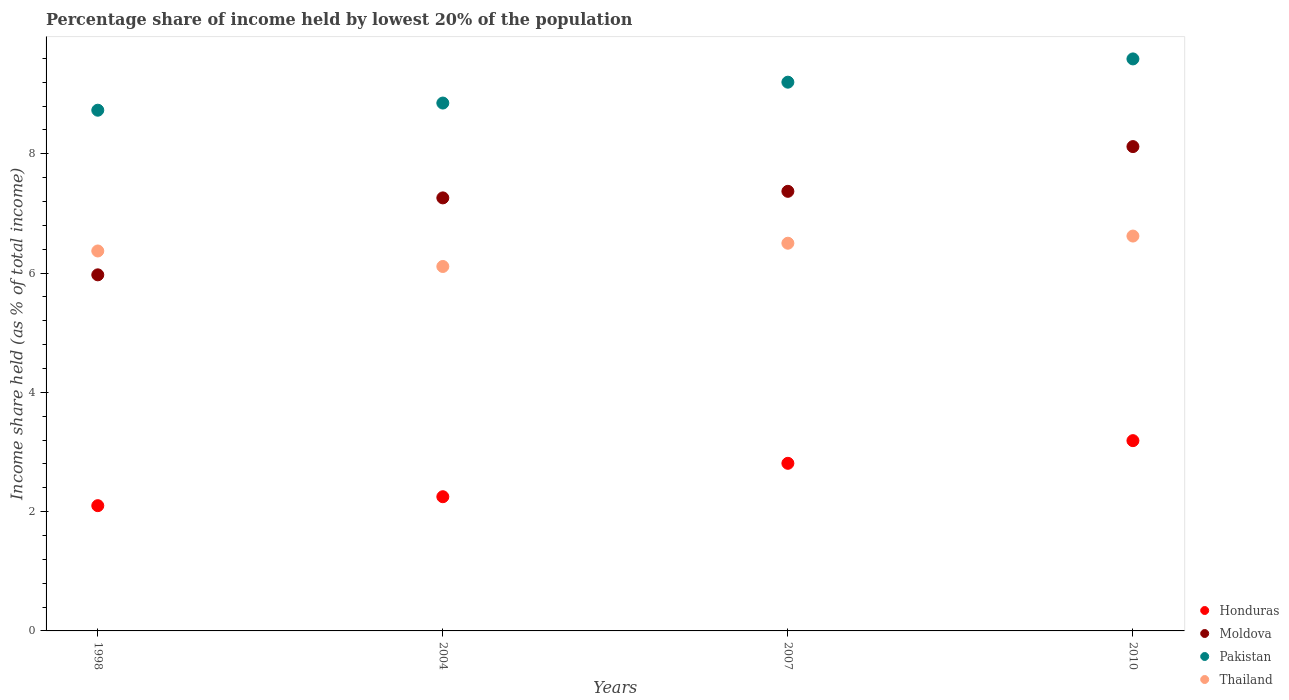How many different coloured dotlines are there?
Offer a very short reply. 4. What is the percentage share of income held by lowest 20% of the population in Pakistan in 2010?
Your answer should be compact. 9.59. Across all years, what is the maximum percentage share of income held by lowest 20% of the population in Thailand?
Keep it short and to the point. 6.62. Across all years, what is the minimum percentage share of income held by lowest 20% of the population in Pakistan?
Offer a very short reply. 8.73. In which year was the percentage share of income held by lowest 20% of the population in Honduras maximum?
Provide a succinct answer. 2010. What is the total percentage share of income held by lowest 20% of the population in Pakistan in the graph?
Provide a succinct answer. 36.37. What is the difference between the percentage share of income held by lowest 20% of the population in Honduras in 1998 and that in 2004?
Provide a succinct answer. -0.15. What is the difference between the percentage share of income held by lowest 20% of the population in Honduras in 1998 and the percentage share of income held by lowest 20% of the population in Thailand in 2007?
Make the answer very short. -4.4. What is the average percentage share of income held by lowest 20% of the population in Thailand per year?
Your answer should be compact. 6.4. In the year 1998, what is the difference between the percentage share of income held by lowest 20% of the population in Thailand and percentage share of income held by lowest 20% of the population in Honduras?
Make the answer very short. 4.27. In how many years, is the percentage share of income held by lowest 20% of the population in Honduras greater than 0.4 %?
Provide a short and direct response. 4. What is the ratio of the percentage share of income held by lowest 20% of the population in Moldova in 1998 to that in 2004?
Provide a short and direct response. 0.82. Is the difference between the percentage share of income held by lowest 20% of the population in Thailand in 2004 and 2010 greater than the difference between the percentage share of income held by lowest 20% of the population in Honduras in 2004 and 2010?
Keep it short and to the point. Yes. What is the difference between the highest and the second highest percentage share of income held by lowest 20% of the population in Honduras?
Your answer should be compact. 0.38. What is the difference between the highest and the lowest percentage share of income held by lowest 20% of the population in Moldova?
Ensure brevity in your answer.  2.15. Is it the case that in every year, the sum of the percentage share of income held by lowest 20% of the population in Honduras and percentage share of income held by lowest 20% of the population in Moldova  is greater than the sum of percentage share of income held by lowest 20% of the population in Thailand and percentage share of income held by lowest 20% of the population in Pakistan?
Ensure brevity in your answer.  Yes. Is it the case that in every year, the sum of the percentage share of income held by lowest 20% of the population in Thailand and percentage share of income held by lowest 20% of the population in Pakistan  is greater than the percentage share of income held by lowest 20% of the population in Honduras?
Ensure brevity in your answer.  Yes. Is the percentage share of income held by lowest 20% of the population in Moldova strictly greater than the percentage share of income held by lowest 20% of the population in Honduras over the years?
Make the answer very short. Yes. Are the values on the major ticks of Y-axis written in scientific E-notation?
Provide a succinct answer. No. Does the graph contain grids?
Your answer should be compact. No. How many legend labels are there?
Offer a terse response. 4. What is the title of the graph?
Provide a succinct answer. Percentage share of income held by lowest 20% of the population. Does "Kiribati" appear as one of the legend labels in the graph?
Provide a short and direct response. No. What is the label or title of the X-axis?
Offer a terse response. Years. What is the label or title of the Y-axis?
Make the answer very short. Income share held (as % of total income). What is the Income share held (as % of total income) in Honduras in 1998?
Give a very brief answer. 2.1. What is the Income share held (as % of total income) in Moldova in 1998?
Keep it short and to the point. 5.97. What is the Income share held (as % of total income) of Pakistan in 1998?
Offer a very short reply. 8.73. What is the Income share held (as % of total income) in Thailand in 1998?
Provide a succinct answer. 6.37. What is the Income share held (as % of total income) in Honduras in 2004?
Your response must be concise. 2.25. What is the Income share held (as % of total income) of Moldova in 2004?
Ensure brevity in your answer.  7.26. What is the Income share held (as % of total income) in Pakistan in 2004?
Ensure brevity in your answer.  8.85. What is the Income share held (as % of total income) in Thailand in 2004?
Your answer should be very brief. 6.11. What is the Income share held (as % of total income) in Honduras in 2007?
Provide a succinct answer. 2.81. What is the Income share held (as % of total income) of Moldova in 2007?
Provide a short and direct response. 7.37. What is the Income share held (as % of total income) in Honduras in 2010?
Ensure brevity in your answer.  3.19. What is the Income share held (as % of total income) in Moldova in 2010?
Offer a very short reply. 8.12. What is the Income share held (as % of total income) of Pakistan in 2010?
Provide a short and direct response. 9.59. What is the Income share held (as % of total income) of Thailand in 2010?
Your answer should be very brief. 6.62. Across all years, what is the maximum Income share held (as % of total income) in Honduras?
Your response must be concise. 3.19. Across all years, what is the maximum Income share held (as % of total income) in Moldova?
Your answer should be very brief. 8.12. Across all years, what is the maximum Income share held (as % of total income) in Pakistan?
Give a very brief answer. 9.59. Across all years, what is the maximum Income share held (as % of total income) in Thailand?
Keep it short and to the point. 6.62. Across all years, what is the minimum Income share held (as % of total income) in Honduras?
Provide a succinct answer. 2.1. Across all years, what is the minimum Income share held (as % of total income) in Moldova?
Your answer should be compact. 5.97. Across all years, what is the minimum Income share held (as % of total income) of Pakistan?
Offer a very short reply. 8.73. Across all years, what is the minimum Income share held (as % of total income) in Thailand?
Your answer should be compact. 6.11. What is the total Income share held (as % of total income) in Honduras in the graph?
Ensure brevity in your answer.  10.35. What is the total Income share held (as % of total income) in Moldova in the graph?
Keep it short and to the point. 28.72. What is the total Income share held (as % of total income) of Pakistan in the graph?
Ensure brevity in your answer.  36.37. What is the total Income share held (as % of total income) in Thailand in the graph?
Keep it short and to the point. 25.6. What is the difference between the Income share held (as % of total income) of Moldova in 1998 and that in 2004?
Your answer should be compact. -1.29. What is the difference between the Income share held (as % of total income) in Pakistan in 1998 and that in 2004?
Keep it short and to the point. -0.12. What is the difference between the Income share held (as % of total income) of Thailand in 1998 and that in 2004?
Your answer should be very brief. 0.26. What is the difference between the Income share held (as % of total income) in Honduras in 1998 and that in 2007?
Ensure brevity in your answer.  -0.71. What is the difference between the Income share held (as % of total income) of Moldova in 1998 and that in 2007?
Give a very brief answer. -1.4. What is the difference between the Income share held (as % of total income) of Pakistan in 1998 and that in 2007?
Make the answer very short. -0.47. What is the difference between the Income share held (as % of total income) in Thailand in 1998 and that in 2007?
Your response must be concise. -0.13. What is the difference between the Income share held (as % of total income) of Honduras in 1998 and that in 2010?
Offer a very short reply. -1.09. What is the difference between the Income share held (as % of total income) of Moldova in 1998 and that in 2010?
Ensure brevity in your answer.  -2.15. What is the difference between the Income share held (as % of total income) of Pakistan in 1998 and that in 2010?
Offer a terse response. -0.86. What is the difference between the Income share held (as % of total income) of Thailand in 1998 and that in 2010?
Ensure brevity in your answer.  -0.25. What is the difference between the Income share held (as % of total income) of Honduras in 2004 and that in 2007?
Your answer should be very brief. -0.56. What is the difference between the Income share held (as % of total income) in Moldova in 2004 and that in 2007?
Your answer should be very brief. -0.11. What is the difference between the Income share held (as % of total income) in Pakistan in 2004 and that in 2007?
Make the answer very short. -0.35. What is the difference between the Income share held (as % of total income) of Thailand in 2004 and that in 2007?
Make the answer very short. -0.39. What is the difference between the Income share held (as % of total income) in Honduras in 2004 and that in 2010?
Your answer should be compact. -0.94. What is the difference between the Income share held (as % of total income) in Moldova in 2004 and that in 2010?
Provide a succinct answer. -0.86. What is the difference between the Income share held (as % of total income) of Pakistan in 2004 and that in 2010?
Offer a terse response. -0.74. What is the difference between the Income share held (as % of total income) of Thailand in 2004 and that in 2010?
Give a very brief answer. -0.51. What is the difference between the Income share held (as % of total income) of Honduras in 2007 and that in 2010?
Your answer should be very brief. -0.38. What is the difference between the Income share held (as % of total income) in Moldova in 2007 and that in 2010?
Ensure brevity in your answer.  -0.75. What is the difference between the Income share held (as % of total income) of Pakistan in 2007 and that in 2010?
Keep it short and to the point. -0.39. What is the difference between the Income share held (as % of total income) in Thailand in 2007 and that in 2010?
Provide a succinct answer. -0.12. What is the difference between the Income share held (as % of total income) of Honduras in 1998 and the Income share held (as % of total income) of Moldova in 2004?
Give a very brief answer. -5.16. What is the difference between the Income share held (as % of total income) of Honduras in 1998 and the Income share held (as % of total income) of Pakistan in 2004?
Make the answer very short. -6.75. What is the difference between the Income share held (as % of total income) of Honduras in 1998 and the Income share held (as % of total income) of Thailand in 2004?
Offer a very short reply. -4.01. What is the difference between the Income share held (as % of total income) of Moldova in 1998 and the Income share held (as % of total income) of Pakistan in 2004?
Your answer should be compact. -2.88. What is the difference between the Income share held (as % of total income) in Moldova in 1998 and the Income share held (as % of total income) in Thailand in 2004?
Your response must be concise. -0.14. What is the difference between the Income share held (as % of total income) of Pakistan in 1998 and the Income share held (as % of total income) of Thailand in 2004?
Provide a short and direct response. 2.62. What is the difference between the Income share held (as % of total income) in Honduras in 1998 and the Income share held (as % of total income) in Moldova in 2007?
Keep it short and to the point. -5.27. What is the difference between the Income share held (as % of total income) of Moldova in 1998 and the Income share held (as % of total income) of Pakistan in 2007?
Ensure brevity in your answer.  -3.23. What is the difference between the Income share held (as % of total income) of Moldova in 1998 and the Income share held (as % of total income) of Thailand in 2007?
Provide a short and direct response. -0.53. What is the difference between the Income share held (as % of total income) of Pakistan in 1998 and the Income share held (as % of total income) of Thailand in 2007?
Your answer should be compact. 2.23. What is the difference between the Income share held (as % of total income) in Honduras in 1998 and the Income share held (as % of total income) in Moldova in 2010?
Your response must be concise. -6.02. What is the difference between the Income share held (as % of total income) of Honduras in 1998 and the Income share held (as % of total income) of Pakistan in 2010?
Keep it short and to the point. -7.49. What is the difference between the Income share held (as % of total income) in Honduras in 1998 and the Income share held (as % of total income) in Thailand in 2010?
Provide a succinct answer. -4.52. What is the difference between the Income share held (as % of total income) in Moldova in 1998 and the Income share held (as % of total income) in Pakistan in 2010?
Your answer should be compact. -3.62. What is the difference between the Income share held (as % of total income) of Moldova in 1998 and the Income share held (as % of total income) of Thailand in 2010?
Make the answer very short. -0.65. What is the difference between the Income share held (as % of total income) of Pakistan in 1998 and the Income share held (as % of total income) of Thailand in 2010?
Your response must be concise. 2.11. What is the difference between the Income share held (as % of total income) of Honduras in 2004 and the Income share held (as % of total income) of Moldova in 2007?
Give a very brief answer. -5.12. What is the difference between the Income share held (as % of total income) of Honduras in 2004 and the Income share held (as % of total income) of Pakistan in 2007?
Make the answer very short. -6.95. What is the difference between the Income share held (as % of total income) in Honduras in 2004 and the Income share held (as % of total income) in Thailand in 2007?
Provide a succinct answer. -4.25. What is the difference between the Income share held (as % of total income) of Moldova in 2004 and the Income share held (as % of total income) of Pakistan in 2007?
Ensure brevity in your answer.  -1.94. What is the difference between the Income share held (as % of total income) in Moldova in 2004 and the Income share held (as % of total income) in Thailand in 2007?
Offer a terse response. 0.76. What is the difference between the Income share held (as % of total income) in Pakistan in 2004 and the Income share held (as % of total income) in Thailand in 2007?
Provide a short and direct response. 2.35. What is the difference between the Income share held (as % of total income) of Honduras in 2004 and the Income share held (as % of total income) of Moldova in 2010?
Keep it short and to the point. -5.87. What is the difference between the Income share held (as % of total income) of Honduras in 2004 and the Income share held (as % of total income) of Pakistan in 2010?
Provide a short and direct response. -7.34. What is the difference between the Income share held (as % of total income) in Honduras in 2004 and the Income share held (as % of total income) in Thailand in 2010?
Your answer should be very brief. -4.37. What is the difference between the Income share held (as % of total income) of Moldova in 2004 and the Income share held (as % of total income) of Pakistan in 2010?
Your response must be concise. -2.33. What is the difference between the Income share held (as % of total income) in Moldova in 2004 and the Income share held (as % of total income) in Thailand in 2010?
Offer a terse response. 0.64. What is the difference between the Income share held (as % of total income) in Pakistan in 2004 and the Income share held (as % of total income) in Thailand in 2010?
Your answer should be compact. 2.23. What is the difference between the Income share held (as % of total income) of Honduras in 2007 and the Income share held (as % of total income) of Moldova in 2010?
Keep it short and to the point. -5.31. What is the difference between the Income share held (as % of total income) in Honduras in 2007 and the Income share held (as % of total income) in Pakistan in 2010?
Your response must be concise. -6.78. What is the difference between the Income share held (as % of total income) of Honduras in 2007 and the Income share held (as % of total income) of Thailand in 2010?
Your answer should be very brief. -3.81. What is the difference between the Income share held (as % of total income) in Moldova in 2007 and the Income share held (as % of total income) in Pakistan in 2010?
Provide a succinct answer. -2.22. What is the difference between the Income share held (as % of total income) in Pakistan in 2007 and the Income share held (as % of total income) in Thailand in 2010?
Provide a short and direct response. 2.58. What is the average Income share held (as % of total income) in Honduras per year?
Give a very brief answer. 2.59. What is the average Income share held (as % of total income) of Moldova per year?
Keep it short and to the point. 7.18. What is the average Income share held (as % of total income) of Pakistan per year?
Ensure brevity in your answer.  9.09. In the year 1998, what is the difference between the Income share held (as % of total income) of Honduras and Income share held (as % of total income) of Moldova?
Provide a short and direct response. -3.87. In the year 1998, what is the difference between the Income share held (as % of total income) of Honduras and Income share held (as % of total income) of Pakistan?
Give a very brief answer. -6.63. In the year 1998, what is the difference between the Income share held (as % of total income) in Honduras and Income share held (as % of total income) in Thailand?
Make the answer very short. -4.27. In the year 1998, what is the difference between the Income share held (as % of total income) of Moldova and Income share held (as % of total income) of Pakistan?
Your response must be concise. -2.76. In the year 1998, what is the difference between the Income share held (as % of total income) of Moldova and Income share held (as % of total income) of Thailand?
Your response must be concise. -0.4. In the year 1998, what is the difference between the Income share held (as % of total income) of Pakistan and Income share held (as % of total income) of Thailand?
Give a very brief answer. 2.36. In the year 2004, what is the difference between the Income share held (as % of total income) in Honduras and Income share held (as % of total income) in Moldova?
Offer a very short reply. -5.01. In the year 2004, what is the difference between the Income share held (as % of total income) in Honduras and Income share held (as % of total income) in Thailand?
Provide a short and direct response. -3.86. In the year 2004, what is the difference between the Income share held (as % of total income) in Moldova and Income share held (as % of total income) in Pakistan?
Provide a short and direct response. -1.59. In the year 2004, what is the difference between the Income share held (as % of total income) in Moldova and Income share held (as % of total income) in Thailand?
Your answer should be very brief. 1.15. In the year 2004, what is the difference between the Income share held (as % of total income) in Pakistan and Income share held (as % of total income) in Thailand?
Provide a short and direct response. 2.74. In the year 2007, what is the difference between the Income share held (as % of total income) in Honduras and Income share held (as % of total income) in Moldova?
Give a very brief answer. -4.56. In the year 2007, what is the difference between the Income share held (as % of total income) of Honduras and Income share held (as % of total income) of Pakistan?
Offer a terse response. -6.39. In the year 2007, what is the difference between the Income share held (as % of total income) in Honduras and Income share held (as % of total income) in Thailand?
Keep it short and to the point. -3.69. In the year 2007, what is the difference between the Income share held (as % of total income) in Moldova and Income share held (as % of total income) in Pakistan?
Ensure brevity in your answer.  -1.83. In the year 2007, what is the difference between the Income share held (as % of total income) in Moldova and Income share held (as % of total income) in Thailand?
Keep it short and to the point. 0.87. In the year 2007, what is the difference between the Income share held (as % of total income) in Pakistan and Income share held (as % of total income) in Thailand?
Make the answer very short. 2.7. In the year 2010, what is the difference between the Income share held (as % of total income) in Honduras and Income share held (as % of total income) in Moldova?
Provide a succinct answer. -4.93. In the year 2010, what is the difference between the Income share held (as % of total income) in Honduras and Income share held (as % of total income) in Pakistan?
Offer a very short reply. -6.4. In the year 2010, what is the difference between the Income share held (as % of total income) of Honduras and Income share held (as % of total income) of Thailand?
Provide a succinct answer. -3.43. In the year 2010, what is the difference between the Income share held (as % of total income) of Moldova and Income share held (as % of total income) of Pakistan?
Provide a short and direct response. -1.47. In the year 2010, what is the difference between the Income share held (as % of total income) of Pakistan and Income share held (as % of total income) of Thailand?
Provide a succinct answer. 2.97. What is the ratio of the Income share held (as % of total income) in Honduras in 1998 to that in 2004?
Offer a terse response. 0.93. What is the ratio of the Income share held (as % of total income) in Moldova in 1998 to that in 2004?
Your response must be concise. 0.82. What is the ratio of the Income share held (as % of total income) in Pakistan in 1998 to that in 2004?
Offer a very short reply. 0.99. What is the ratio of the Income share held (as % of total income) in Thailand in 1998 to that in 2004?
Give a very brief answer. 1.04. What is the ratio of the Income share held (as % of total income) in Honduras in 1998 to that in 2007?
Offer a terse response. 0.75. What is the ratio of the Income share held (as % of total income) of Moldova in 1998 to that in 2007?
Offer a terse response. 0.81. What is the ratio of the Income share held (as % of total income) of Pakistan in 1998 to that in 2007?
Provide a succinct answer. 0.95. What is the ratio of the Income share held (as % of total income) in Honduras in 1998 to that in 2010?
Your answer should be compact. 0.66. What is the ratio of the Income share held (as % of total income) in Moldova in 1998 to that in 2010?
Ensure brevity in your answer.  0.74. What is the ratio of the Income share held (as % of total income) of Pakistan in 1998 to that in 2010?
Provide a short and direct response. 0.91. What is the ratio of the Income share held (as % of total income) in Thailand in 1998 to that in 2010?
Ensure brevity in your answer.  0.96. What is the ratio of the Income share held (as % of total income) in Honduras in 2004 to that in 2007?
Your answer should be very brief. 0.8. What is the ratio of the Income share held (as % of total income) in Moldova in 2004 to that in 2007?
Make the answer very short. 0.99. What is the ratio of the Income share held (as % of total income) of Pakistan in 2004 to that in 2007?
Offer a very short reply. 0.96. What is the ratio of the Income share held (as % of total income) in Thailand in 2004 to that in 2007?
Offer a terse response. 0.94. What is the ratio of the Income share held (as % of total income) in Honduras in 2004 to that in 2010?
Keep it short and to the point. 0.71. What is the ratio of the Income share held (as % of total income) in Moldova in 2004 to that in 2010?
Your answer should be compact. 0.89. What is the ratio of the Income share held (as % of total income) of Pakistan in 2004 to that in 2010?
Offer a terse response. 0.92. What is the ratio of the Income share held (as % of total income) of Thailand in 2004 to that in 2010?
Provide a succinct answer. 0.92. What is the ratio of the Income share held (as % of total income) of Honduras in 2007 to that in 2010?
Make the answer very short. 0.88. What is the ratio of the Income share held (as % of total income) in Moldova in 2007 to that in 2010?
Ensure brevity in your answer.  0.91. What is the ratio of the Income share held (as % of total income) of Pakistan in 2007 to that in 2010?
Ensure brevity in your answer.  0.96. What is the ratio of the Income share held (as % of total income) of Thailand in 2007 to that in 2010?
Offer a very short reply. 0.98. What is the difference between the highest and the second highest Income share held (as % of total income) of Honduras?
Offer a terse response. 0.38. What is the difference between the highest and the second highest Income share held (as % of total income) in Moldova?
Give a very brief answer. 0.75. What is the difference between the highest and the second highest Income share held (as % of total income) of Pakistan?
Offer a terse response. 0.39. What is the difference between the highest and the second highest Income share held (as % of total income) in Thailand?
Provide a short and direct response. 0.12. What is the difference between the highest and the lowest Income share held (as % of total income) in Honduras?
Offer a very short reply. 1.09. What is the difference between the highest and the lowest Income share held (as % of total income) in Moldova?
Your answer should be compact. 2.15. What is the difference between the highest and the lowest Income share held (as % of total income) in Pakistan?
Provide a succinct answer. 0.86. What is the difference between the highest and the lowest Income share held (as % of total income) of Thailand?
Provide a short and direct response. 0.51. 